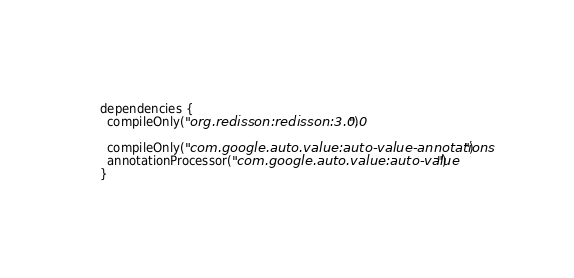<code> <loc_0><loc_0><loc_500><loc_500><_Kotlin_>
dependencies {
  compileOnly("org.redisson:redisson:3.0.0")

  compileOnly("com.google.auto.value:auto-value-annotations")
  annotationProcessor("com.google.auto.value:auto-value")
}
</code> 